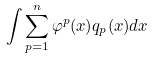Convert formula to latex. <formula><loc_0><loc_0><loc_500><loc_500>\int \sum _ { p = 1 } ^ { n } \varphi ^ { p } ( x ) q _ { p } ( x ) d x</formula> 